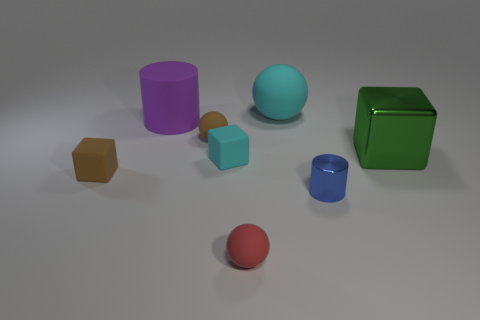There is a large sphere; is it the same color as the matte cube to the right of the big purple object?
Ensure brevity in your answer.  Yes. There is a small rubber object that is the same color as the big ball; what shape is it?
Make the answer very short. Cube. The big thing that is made of the same material as the big purple cylinder is what color?
Make the answer very short. Cyan. Is the large cyan thing the same shape as the tiny shiny object?
Offer a very short reply. No. There is a tiny cube to the right of the small matte ball behind the cyan cube; is there a small cyan object to the right of it?
Offer a very short reply. No. How many matte things have the same color as the large rubber sphere?
Keep it short and to the point. 1. There is a green metal thing that is the same size as the purple cylinder; what shape is it?
Ensure brevity in your answer.  Cube. Are there any blue cylinders in front of the big purple rubber object?
Your answer should be compact. Yes. Do the cyan rubber block and the red matte object have the same size?
Ensure brevity in your answer.  Yes. There is a tiny object to the right of the red rubber object; what shape is it?
Offer a very short reply. Cylinder. 